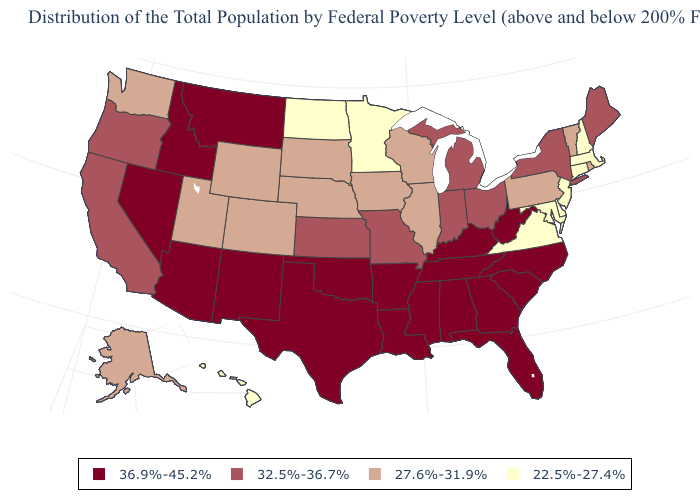Name the states that have a value in the range 36.9%-45.2%?
Short answer required. Alabama, Arizona, Arkansas, Florida, Georgia, Idaho, Kentucky, Louisiana, Mississippi, Montana, Nevada, New Mexico, North Carolina, Oklahoma, South Carolina, Tennessee, Texas, West Virginia. What is the value of Nevada?
Quick response, please. 36.9%-45.2%. Name the states that have a value in the range 32.5%-36.7%?
Concise answer only. California, Indiana, Kansas, Maine, Michigan, Missouri, New York, Ohio, Oregon. Name the states that have a value in the range 22.5%-27.4%?
Be succinct. Connecticut, Delaware, Hawaii, Maryland, Massachusetts, Minnesota, New Hampshire, New Jersey, North Dakota, Virginia. Does Maryland have the lowest value in the South?
Short answer required. Yes. Does Connecticut have the lowest value in the USA?
Concise answer only. Yes. How many symbols are there in the legend?
Be succinct. 4. What is the lowest value in the USA?
Give a very brief answer. 22.5%-27.4%. Is the legend a continuous bar?
Give a very brief answer. No. Does Florida have the highest value in the USA?
Keep it brief. Yes. How many symbols are there in the legend?
Give a very brief answer. 4. Does Maryland have a lower value than North Dakota?
Give a very brief answer. No. Name the states that have a value in the range 22.5%-27.4%?
Concise answer only. Connecticut, Delaware, Hawaii, Maryland, Massachusetts, Minnesota, New Hampshire, New Jersey, North Dakota, Virginia. 